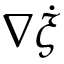Convert formula to latex. <formula><loc_0><loc_0><loc_500><loc_500>\nabla \dot { \xi }</formula> 